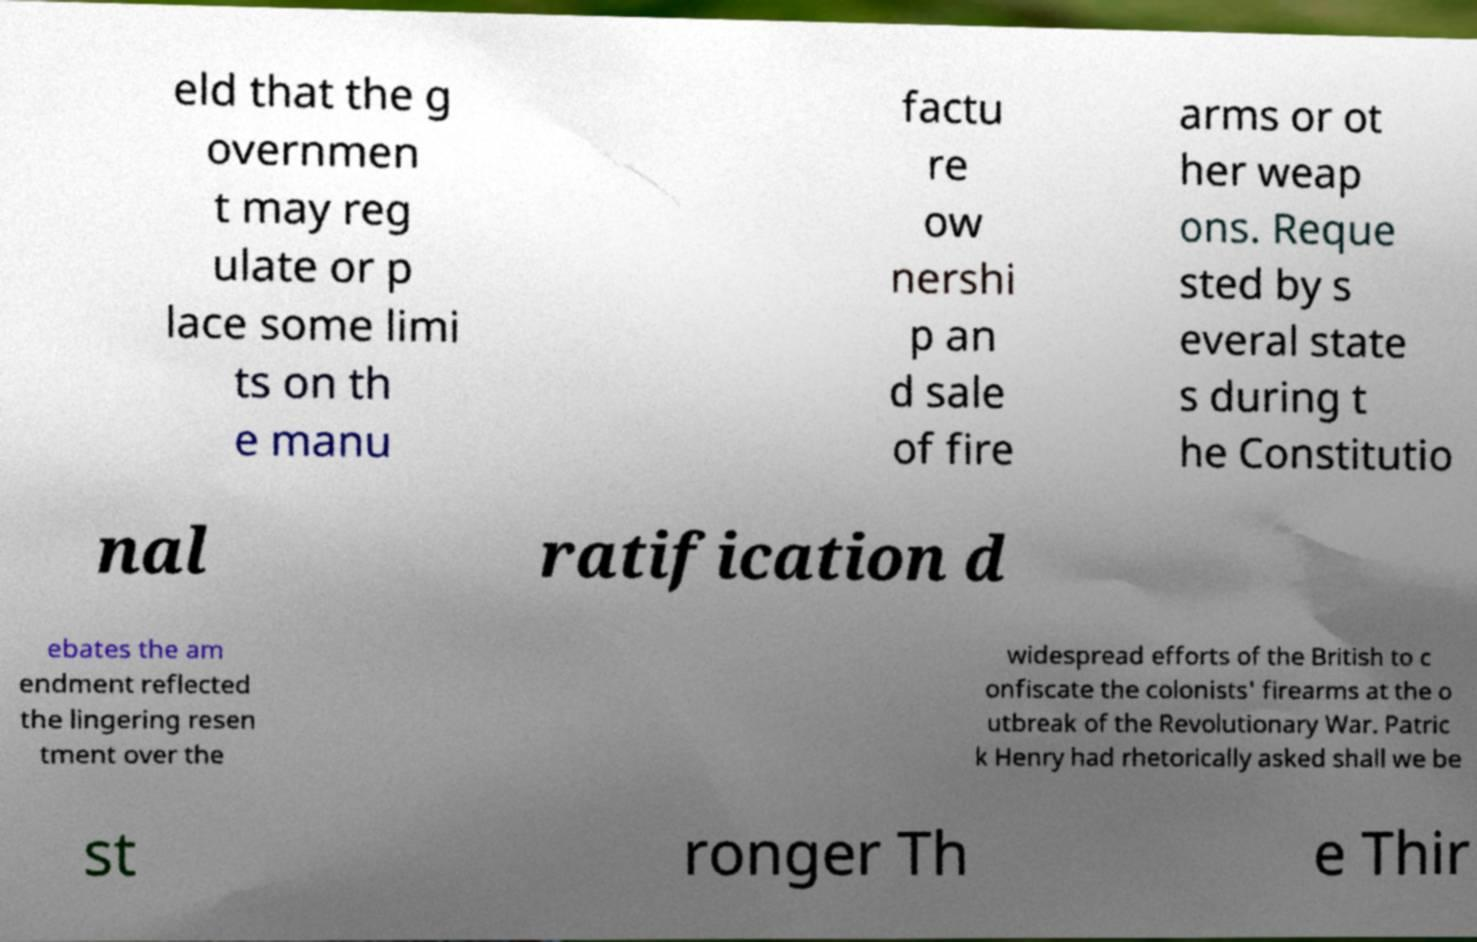For documentation purposes, I need the text within this image transcribed. Could you provide that? eld that the g overnmen t may reg ulate or p lace some limi ts on th e manu factu re ow nershi p an d sale of fire arms or ot her weap ons. Reque sted by s everal state s during t he Constitutio nal ratification d ebates the am endment reflected the lingering resen tment over the widespread efforts of the British to c onfiscate the colonists' firearms at the o utbreak of the Revolutionary War. Patric k Henry had rhetorically asked shall we be st ronger Th e Thir 